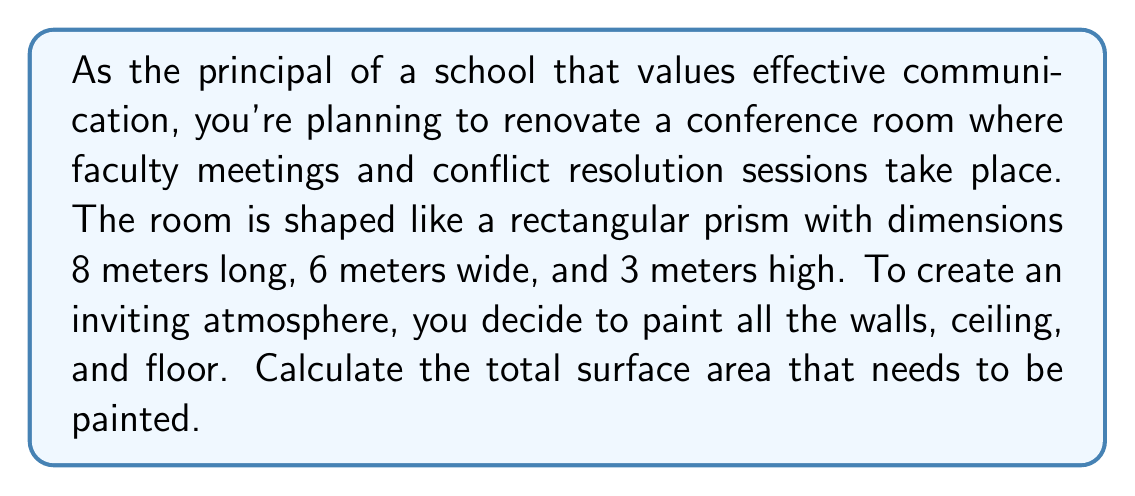Teach me how to tackle this problem. To solve this problem, we need to calculate the surface area of a rectangular prism. The surface area of a rectangular prism is the sum of the areas of all six faces (two identical faces for each dimension).

Let's break it down step-by-step:

1. Identify the dimensions:
   Length (l) = 8 m
   Width (w) = 6 m
   Height (h) = 3 m

2. Calculate the area of each face:
   - Front and back faces (length × height): $A_1 = l \times h = 8 \times 3 = 24$ m²
   - Left and right faces (width × height): $A_2 = w \times h = 6 \times 3 = 18$ m²
   - Top and bottom faces (length × width): $A_3 = l \times w = 8 \times 6 = 48$ m²

3. Calculate the total surface area:
   Total surface area = 2(Front face + Side face + Top face)
   $$SA = 2(A_1 + A_2 + A_3)$$
   $$SA = 2(24 + 18 + 48)$$
   $$SA = 2(90)$$
   $$SA = 180\text{ m}^2$$

Therefore, the total surface area that needs to be painted is 180 square meters.
Answer: The total surface area of the conference room that needs to be painted is $180\text{ m}^2$. 